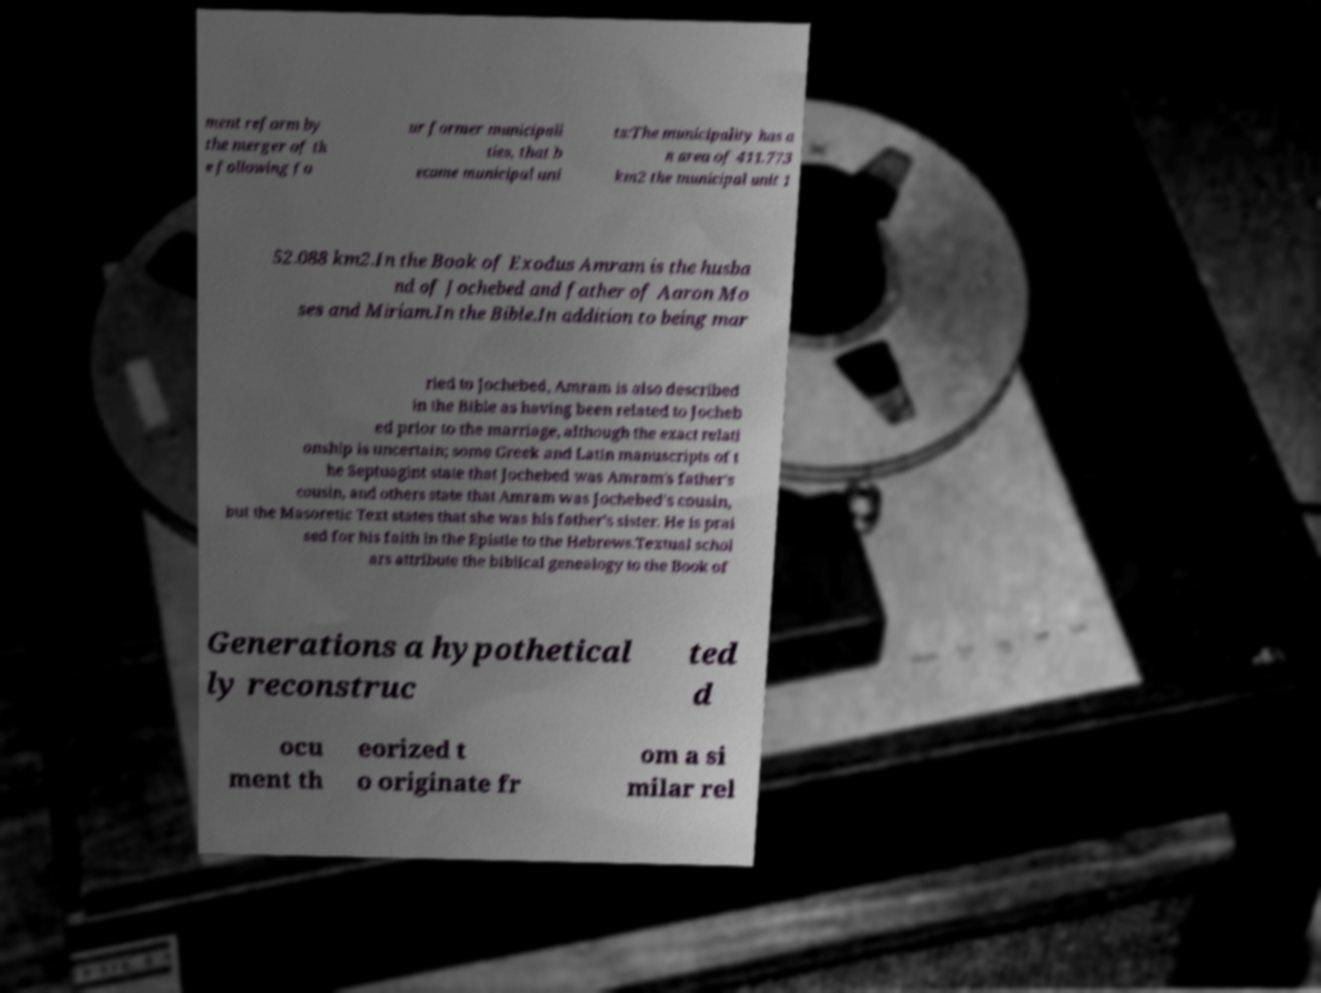I need the written content from this picture converted into text. Can you do that? ment reform by the merger of th e following fo ur former municipali ties, that b ecame municipal uni ts:The municipality has a n area of 411.773 km2 the municipal unit 1 52.088 km2.In the Book of Exodus Amram is the husba nd of Jochebed and father of Aaron Mo ses and Miriam.In the Bible.In addition to being mar ried to Jochebed, Amram is also described in the Bible as having been related to Jocheb ed prior to the marriage, although the exact relati onship is uncertain; some Greek and Latin manuscripts of t he Septuagint state that Jochebed was Amram's father's cousin, and others state that Amram was Jochebed's cousin, but the Masoretic Text states that she was his father's sister. He is prai sed for his faith in the Epistle to the Hebrews.Textual schol ars attribute the biblical genealogy to the Book of Generations a hypothetical ly reconstruc ted d ocu ment th eorized t o originate fr om a si milar rel 